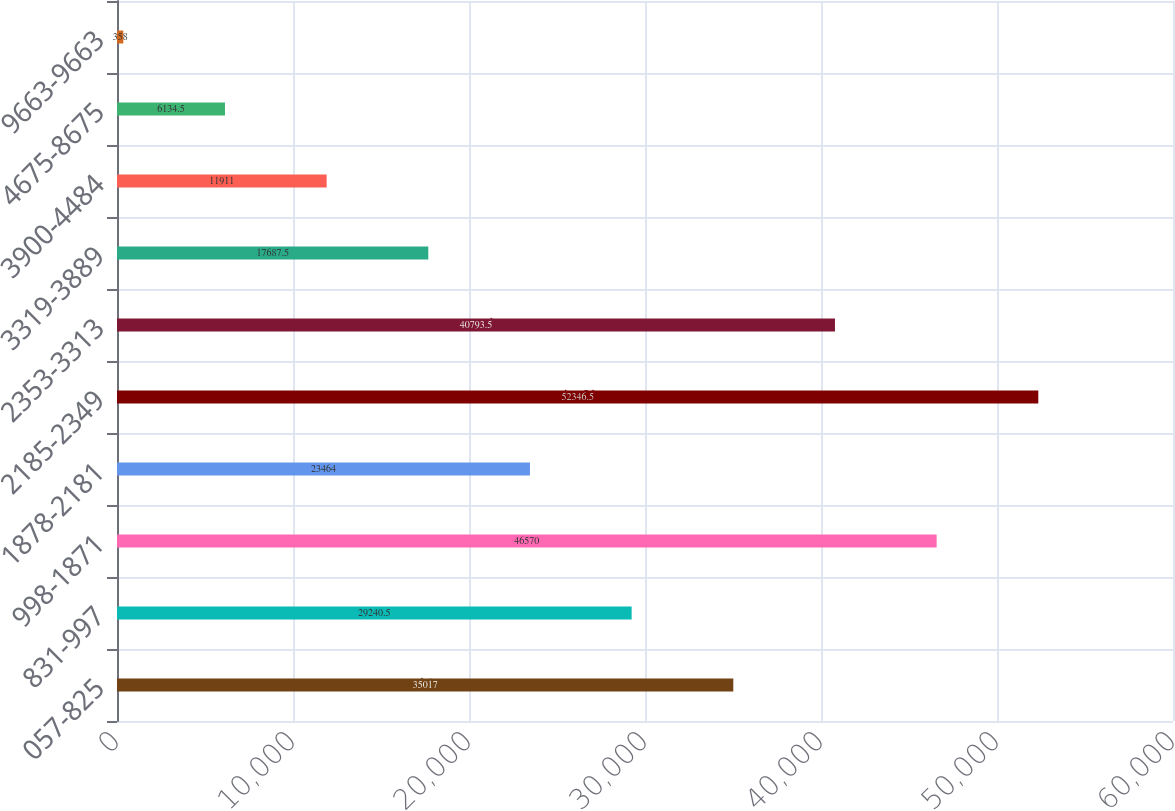Convert chart to OTSL. <chart><loc_0><loc_0><loc_500><loc_500><bar_chart><fcel>057-825<fcel>831-997<fcel>998-1871<fcel>1878-2181<fcel>2185-2349<fcel>2353-3313<fcel>3319-3889<fcel>3900-4484<fcel>4675-8675<fcel>9663-9663<nl><fcel>35017<fcel>29240.5<fcel>46570<fcel>23464<fcel>52346.5<fcel>40793.5<fcel>17687.5<fcel>11911<fcel>6134.5<fcel>358<nl></chart> 